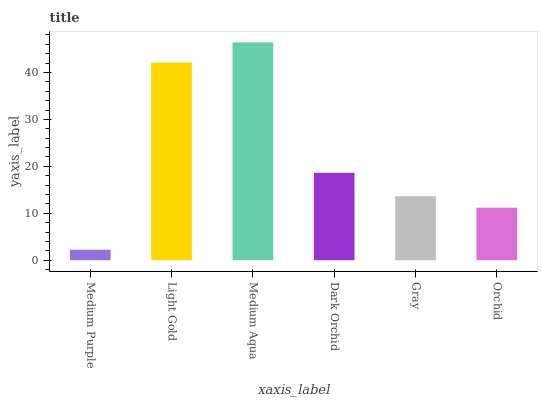Is Light Gold the minimum?
Answer yes or no. No. Is Light Gold the maximum?
Answer yes or no. No. Is Light Gold greater than Medium Purple?
Answer yes or no. Yes. Is Medium Purple less than Light Gold?
Answer yes or no. Yes. Is Medium Purple greater than Light Gold?
Answer yes or no. No. Is Light Gold less than Medium Purple?
Answer yes or no. No. Is Dark Orchid the high median?
Answer yes or no. Yes. Is Gray the low median?
Answer yes or no. Yes. Is Medium Purple the high median?
Answer yes or no. No. Is Orchid the low median?
Answer yes or no. No. 